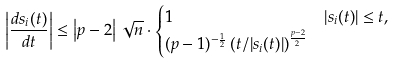Convert formula to latex. <formula><loc_0><loc_0><loc_500><loc_500>\left | \frac { d s _ { i } ( t ) } { d t } \right | & \leq \left | p - 2 \right | \sqrt { n } \cdot \begin{cases} 1 & | s _ { i } ( t ) | \leq t , \\ ( p - 1 ) ^ { - \frac { 1 } { 2 } } \left ( t / | s _ { i } ( t ) | \right ) ^ { \frac { p - 2 } { 2 } } & \end{cases}</formula> 